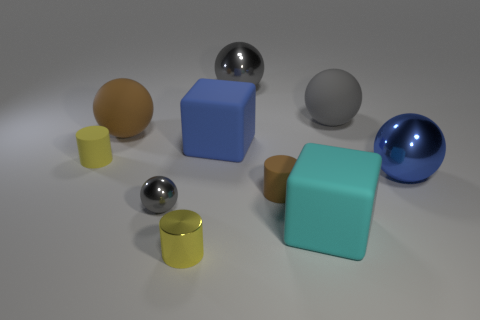What number of other objects are there of the same color as the tiny ball?
Offer a very short reply. 2. There is a matte thing right of the cyan thing; is its size the same as the yellow metal object?
Provide a short and direct response. No. There is a object that is both right of the brown matte cylinder and in front of the brown cylinder; what material is it?
Keep it short and to the point. Rubber. There is a gray matte object that is the same size as the brown ball; what is its shape?
Offer a very short reply. Sphere. What color is the small cylinder that is left of the big brown rubber sphere left of the matte cube that is in front of the blue block?
Keep it short and to the point. Yellow. How many things are either gray balls to the right of the cyan object or large green matte cubes?
Offer a very short reply. 1. What is the material of the blue block that is the same size as the cyan cube?
Provide a succinct answer. Rubber. What is the material of the yellow cylinder to the left of the gray metallic ball in front of the large shiny ball that is on the left side of the large blue shiny sphere?
Your answer should be compact. Rubber. What color is the small ball?
Your answer should be very brief. Gray. How many large objects are either blocks or gray balls?
Ensure brevity in your answer.  4. 